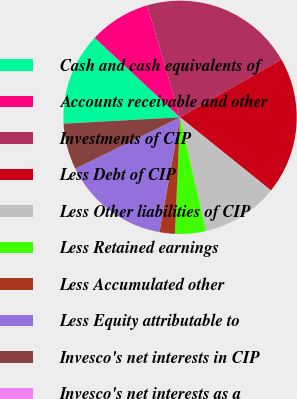Convert chart. <chart><loc_0><loc_0><loc_500><loc_500><pie_chart><fcel>Cash and cash equivalents of<fcel>Accounts receivable and other<fcel>Investments of CIP<fcel>Less Debt of CIP<fcel>Less Other liabilities of CIP<fcel>Less Retained earnings<fcel>Less Accumulated other<fcel>Less Equity attributable to<fcel>Invesco's net interests in CIP<fcel>Invesco's net interests as a<nl><fcel>12.78%<fcel>8.52%<fcel>21.3%<fcel>19.03%<fcel>10.65%<fcel>4.26%<fcel>2.14%<fcel>14.91%<fcel>6.39%<fcel>0.01%<nl></chart> 